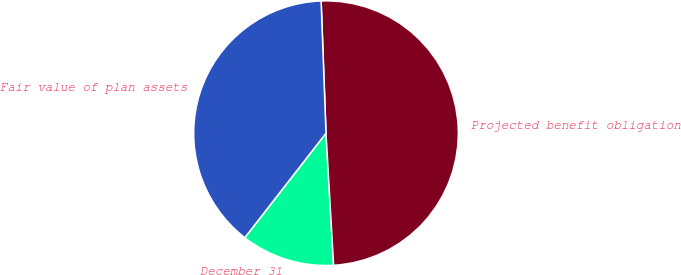<chart> <loc_0><loc_0><loc_500><loc_500><pie_chart><fcel>December 31<fcel>Projected benefit obligation<fcel>Fair value of plan assets<nl><fcel>11.43%<fcel>49.67%<fcel>38.9%<nl></chart> 